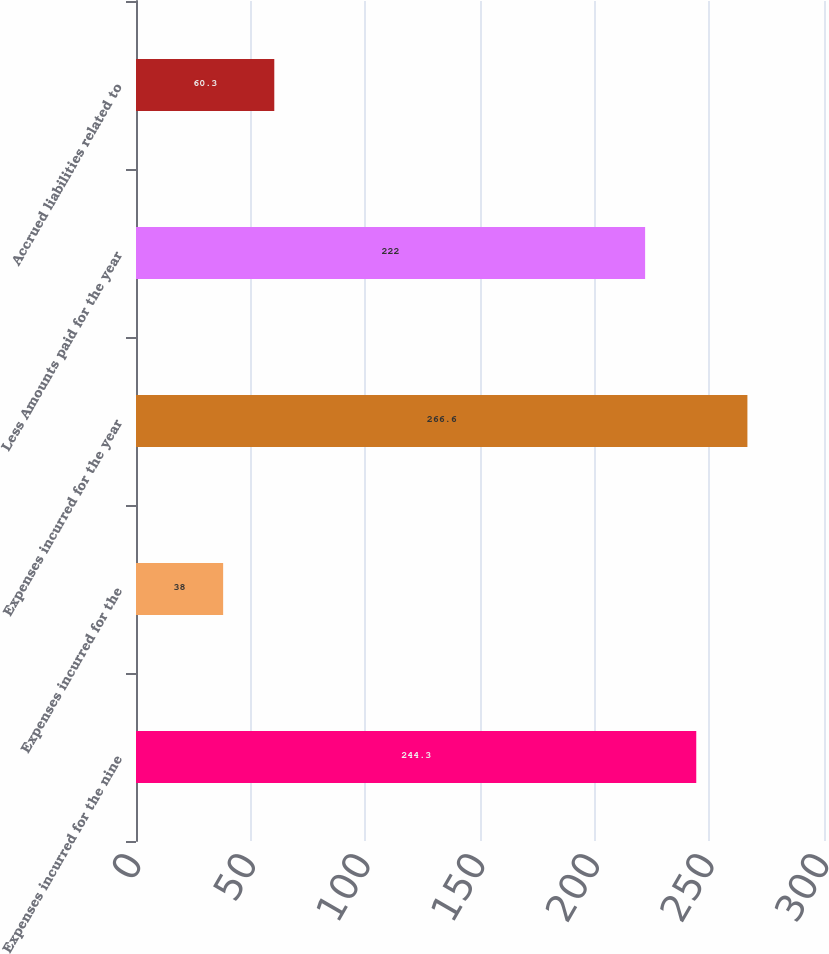<chart> <loc_0><loc_0><loc_500><loc_500><bar_chart><fcel>Expenses incurred for the nine<fcel>Expenses incurred for the<fcel>Expenses incurred for the year<fcel>Less Amounts paid for the year<fcel>Accrued liabilities related to<nl><fcel>244.3<fcel>38<fcel>266.6<fcel>222<fcel>60.3<nl></chart> 